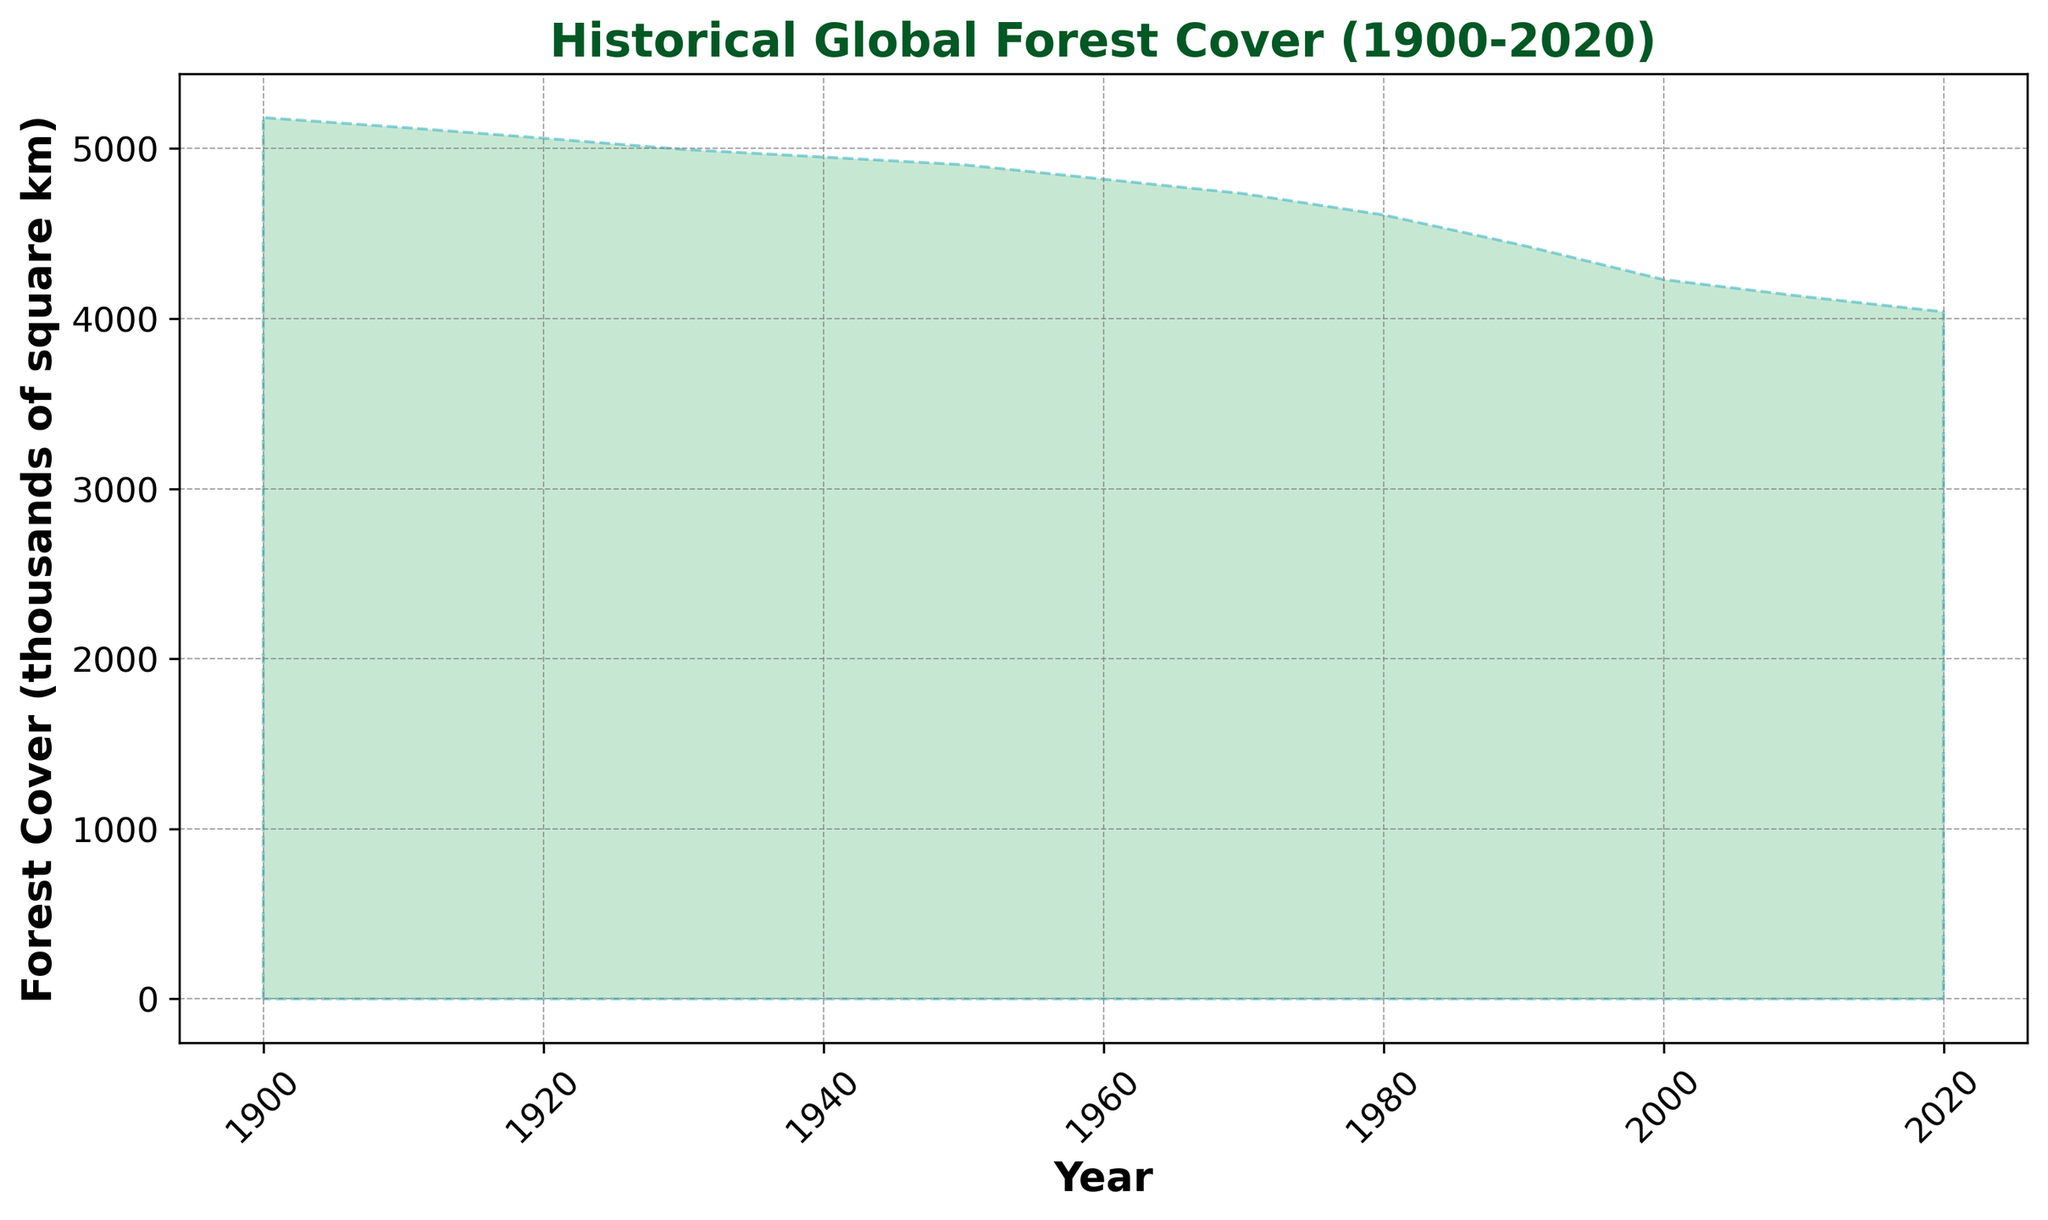What is the range of forest cover observed between 1900 and 2020? To find the range, subtract the lowest forest cover value (4040 in 2020) from the highest forest cover value (5182 in 1900). So, 5182 - 4040 = 1142.
Answer: 1142 Which decade saw the most significant drop in forest cover? From observing the figure, compare the forest cover difference between consecutive decades. The biggest drop in forest cover is between 1980 and 1990 (4610 - 4430 = 180).
Answer: 1980-1990 In which year was the forest cover at 4950 thousand square km? Find the specific year in the figure that corresponds to the forest cover value of 4950. According to the data, this is in 1940.
Answer: 1940 How does the forest cover in 1960 compare to 2020? From the figure, note the forest cover values in 1960 (4820) and in 2020 (4040). subtract these values to see the difference: 4820 - 4040 = 780. 1960 has 780 more forest cover than in 2020.
Answer: 1960 has 780 more What was the average forest cover from 1900 to 1950? Sum the forest cover values from 1900, 1910, 1920, 1930, 1940, and 1950 and divide by the number of years: (5182 + 5124 + 5061 + 4995 + 4950 + 4905) / 6 = 5036.17.
Answer: 5036.17 Which period shows a forest cover value closest to 4500 thousand square km? From the figure, find the year with forest cover values around 4500. 1990 shows 4430, which is closest to 4500 compared to other years.
Answer: 1990 During which decades does the forest cover visibly decrease in the figure? Examine the figure and note all decades where the forest cover values visibly drop. These are the decades given in the figure: 1910-1920, 1920-1930, 1930-1940, 1940-1950, 1950-1960, 1960-1970, 1970-1980, 1980-1990, 1990-2000, 2000-2010, 2010-2020
Answer: All decades Approximately, what is the decline in forest cover from 1900 to 1950? Subtract the value of forest cover in 1950 (4905) from the value in 1900 (5182). So 5182 - 4905 = 277.
Answer: 277 What is the forest cover value for the year 1980? From the figure, find the forest cover value corresponding to 1980. This value is 4610.
Answer: 4610 